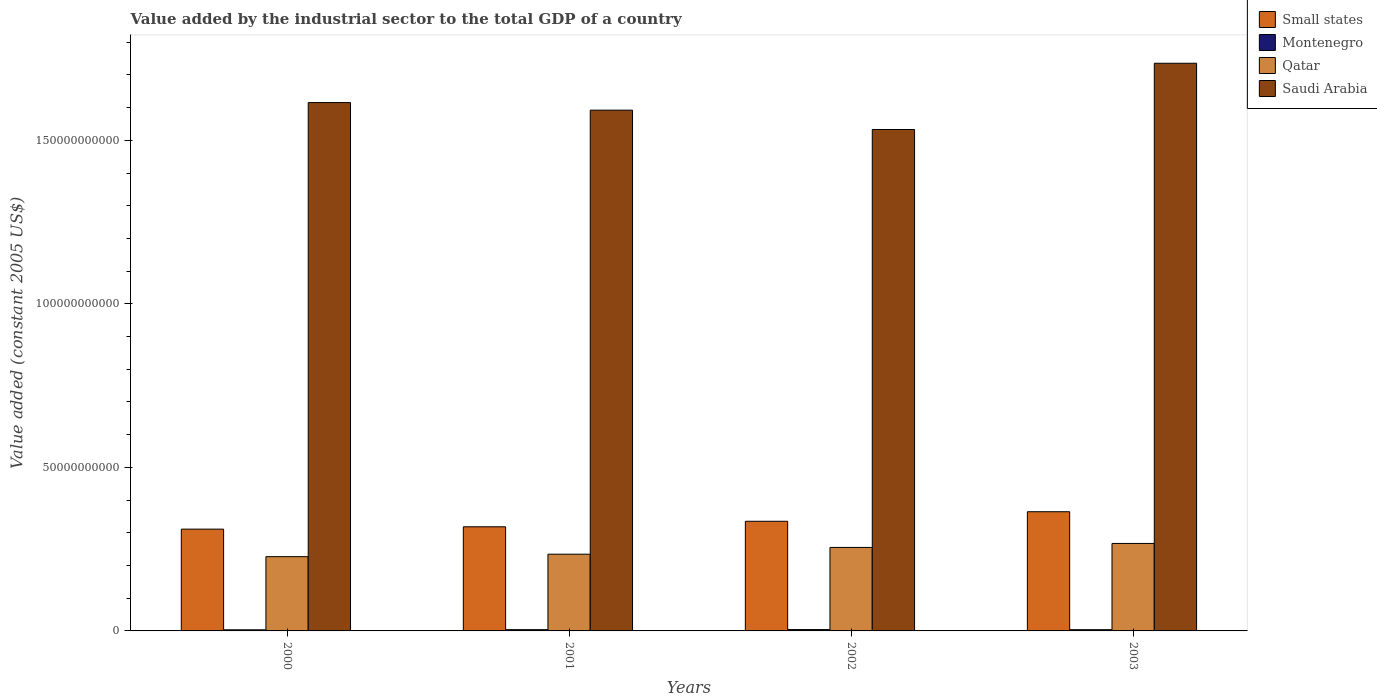How many different coloured bars are there?
Provide a succinct answer. 4. Are the number of bars per tick equal to the number of legend labels?
Keep it short and to the point. Yes. Are the number of bars on each tick of the X-axis equal?
Ensure brevity in your answer.  Yes. In how many cases, is the number of bars for a given year not equal to the number of legend labels?
Your answer should be compact. 0. What is the value added by the industrial sector in Small states in 2001?
Provide a succinct answer. 3.18e+1. Across all years, what is the maximum value added by the industrial sector in Montenegro?
Your answer should be very brief. 4.10e+08. Across all years, what is the minimum value added by the industrial sector in Montenegro?
Your answer should be compact. 3.32e+08. In which year was the value added by the industrial sector in Qatar maximum?
Keep it short and to the point. 2003. In which year was the value added by the industrial sector in Qatar minimum?
Your response must be concise. 2000. What is the total value added by the industrial sector in Saudi Arabia in the graph?
Provide a short and direct response. 6.48e+11. What is the difference between the value added by the industrial sector in Qatar in 2001 and that in 2002?
Offer a terse response. -2.07e+09. What is the difference between the value added by the industrial sector in Small states in 2000 and the value added by the industrial sector in Saudi Arabia in 2001?
Provide a short and direct response. -1.28e+11. What is the average value added by the industrial sector in Small states per year?
Offer a terse response. 3.32e+1. In the year 2000, what is the difference between the value added by the industrial sector in Saudi Arabia and value added by the industrial sector in Small states?
Your answer should be compact. 1.30e+11. What is the ratio of the value added by the industrial sector in Saudi Arabia in 2000 to that in 2001?
Provide a succinct answer. 1.01. Is the difference between the value added by the industrial sector in Saudi Arabia in 2000 and 2001 greater than the difference between the value added by the industrial sector in Small states in 2000 and 2001?
Keep it short and to the point. Yes. What is the difference between the highest and the second highest value added by the industrial sector in Qatar?
Your response must be concise. 1.22e+09. What is the difference between the highest and the lowest value added by the industrial sector in Small states?
Provide a short and direct response. 5.32e+09. In how many years, is the value added by the industrial sector in Small states greater than the average value added by the industrial sector in Small states taken over all years?
Give a very brief answer. 2. Is it the case that in every year, the sum of the value added by the industrial sector in Saudi Arabia and value added by the industrial sector in Qatar is greater than the sum of value added by the industrial sector in Small states and value added by the industrial sector in Montenegro?
Your response must be concise. Yes. What does the 3rd bar from the left in 2000 represents?
Keep it short and to the point. Qatar. What does the 4th bar from the right in 2003 represents?
Offer a very short reply. Small states. Is it the case that in every year, the sum of the value added by the industrial sector in Qatar and value added by the industrial sector in Small states is greater than the value added by the industrial sector in Saudi Arabia?
Provide a succinct answer. No. Are all the bars in the graph horizontal?
Provide a succinct answer. No. How many years are there in the graph?
Your response must be concise. 4. What is the difference between two consecutive major ticks on the Y-axis?
Keep it short and to the point. 5.00e+1. Are the values on the major ticks of Y-axis written in scientific E-notation?
Provide a succinct answer. No. Does the graph contain any zero values?
Your response must be concise. No. Does the graph contain grids?
Provide a short and direct response. No. How many legend labels are there?
Provide a succinct answer. 4. How are the legend labels stacked?
Provide a succinct answer. Vertical. What is the title of the graph?
Your response must be concise. Value added by the industrial sector to the total GDP of a country. Does "Tonga" appear as one of the legend labels in the graph?
Provide a short and direct response. No. What is the label or title of the Y-axis?
Make the answer very short. Value added (constant 2005 US$). What is the Value added (constant 2005 US$) in Small states in 2000?
Keep it short and to the point. 3.11e+1. What is the Value added (constant 2005 US$) in Montenegro in 2000?
Offer a terse response. 3.32e+08. What is the Value added (constant 2005 US$) of Qatar in 2000?
Give a very brief answer. 2.27e+1. What is the Value added (constant 2005 US$) in Saudi Arabia in 2000?
Provide a short and direct response. 1.62e+11. What is the Value added (constant 2005 US$) in Small states in 2001?
Your response must be concise. 3.18e+1. What is the Value added (constant 2005 US$) in Montenegro in 2001?
Offer a terse response. 3.83e+08. What is the Value added (constant 2005 US$) in Qatar in 2001?
Provide a short and direct response. 2.35e+1. What is the Value added (constant 2005 US$) in Saudi Arabia in 2001?
Ensure brevity in your answer.  1.59e+11. What is the Value added (constant 2005 US$) in Small states in 2002?
Offer a terse response. 3.35e+1. What is the Value added (constant 2005 US$) of Montenegro in 2002?
Keep it short and to the point. 4.10e+08. What is the Value added (constant 2005 US$) in Qatar in 2002?
Provide a short and direct response. 2.55e+1. What is the Value added (constant 2005 US$) in Saudi Arabia in 2002?
Provide a succinct answer. 1.53e+11. What is the Value added (constant 2005 US$) in Small states in 2003?
Offer a very short reply. 3.64e+1. What is the Value added (constant 2005 US$) of Montenegro in 2003?
Keep it short and to the point. 3.77e+08. What is the Value added (constant 2005 US$) in Qatar in 2003?
Your answer should be very brief. 2.67e+1. What is the Value added (constant 2005 US$) in Saudi Arabia in 2003?
Provide a short and direct response. 1.74e+11. Across all years, what is the maximum Value added (constant 2005 US$) in Small states?
Make the answer very short. 3.64e+1. Across all years, what is the maximum Value added (constant 2005 US$) of Montenegro?
Your answer should be compact. 4.10e+08. Across all years, what is the maximum Value added (constant 2005 US$) of Qatar?
Provide a succinct answer. 2.67e+1. Across all years, what is the maximum Value added (constant 2005 US$) in Saudi Arabia?
Provide a short and direct response. 1.74e+11. Across all years, what is the minimum Value added (constant 2005 US$) of Small states?
Your response must be concise. 3.11e+1. Across all years, what is the minimum Value added (constant 2005 US$) in Montenegro?
Offer a very short reply. 3.32e+08. Across all years, what is the minimum Value added (constant 2005 US$) in Qatar?
Make the answer very short. 2.27e+1. Across all years, what is the minimum Value added (constant 2005 US$) in Saudi Arabia?
Offer a terse response. 1.53e+11. What is the total Value added (constant 2005 US$) of Small states in the graph?
Offer a terse response. 1.33e+11. What is the total Value added (constant 2005 US$) of Montenegro in the graph?
Ensure brevity in your answer.  1.50e+09. What is the total Value added (constant 2005 US$) in Qatar in the graph?
Offer a very short reply. 9.84e+1. What is the total Value added (constant 2005 US$) of Saudi Arabia in the graph?
Offer a very short reply. 6.48e+11. What is the difference between the Value added (constant 2005 US$) in Small states in 2000 and that in 2001?
Keep it short and to the point. -7.15e+08. What is the difference between the Value added (constant 2005 US$) in Montenegro in 2000 and that in 2001?
Provide a short and direct response. -5.11e+07. What is the difference between the Value added (constant 2005 US$) in Qatar in 2000 and that in 2001?
Make the answer very short. -7.55e+08. What is the difference between the Value added (constant 2005 US$) in Saudi Arabia in 2000 and that in 2001?
Your answer should be compact. 2.31e+09. What is the difference between the Value added (constant 2005 US$) in Small states in 2000 and that in 2002?
Your response must be concise. -2.40e+09. What is the difference between the Value added (constant 2005 US$) of Montenegro in 2000 and that in 2002?
Ensure brevity in your answer.  -7.79e+07. What is the difference between the Value added (constant 2005 US$) of Qatar in 2000 and that in 2002?
Keep it short and to the point. -2.82e+09. What is the difference between the Value added (constant 2005 US$) of Saudi Arabia in 2000 and that in 2002?
Keep it short and to the point. 8.23e+09. What is the difference between the Value added (constant 2005 US$) of Small states in 2000 and that in 2003?
Keep it short and to the point. -5.32e+09. What is the difference between the Value added (constant 2005 US$) in Montenegro in 2000 and that in 2003?
Your answer should be very brief. -4.47e+07. What is the difference between the Value added (constant 2005 US$) of Qatar in 2000 and that in 2003?
Offer a terse response. -4.04e+09. What is the difference between the Value added (constant 2005 US$) in Saudi Arabia in 2000 and that in 2003?
Provide a succinct answer. -1.20e+1. What is the difference between the Value added (constant 2005 US$) of Small states in 2001 and that in 2002?
Offer a very short reply. -1.69e+09. What is the difference between the Value added (constant 2005 US$) of Montenegro in 2001 and that in 2002?
Offer a very short reply. -2.69e+07. What is the difference between the Value added (constant 2005 US$) of Qatar in 2001 and that in 2002?
Give a very brief answer. -2.07e+09. What is the difference between the Value added (constant 2005 US$) of Saudi Arabia in 2001 and that in 2002?
Provide a short and direct response. 5.92e+09. What is the difference between the Value added (constant 2005 US$) in Small states in 2001 and that in 2003?
Ensure brevity in your answer.  -4.60e+09. What is the difference between the Value added (constant 2005 US$) of Montenegro in 2001 and that in 2003?
Your answer should be very brief. 6.39e+06. What is the difference between the Value added (constant 2005 US$) in Qatar in 2001 and that in 2003?
Your answer should be compact. -3.29e+09. What is the difference between the Value added (constant 2005 US$) of Saudi Arabia in 2001 and that in 2003?
Ensure brevity in your answer.  -1.43e+1. What is the difference between the Value added (constant 2005 US$) in Small states in 2002 and that in 2003?
Offer a terse response. -2.92e+09. What is the difference between the Value added (constant 2005 US$) of Montenegro in 2002 and that in 2003?
Offer a terse response. 3.33e+07. What is the difference between the Value added (constant 2005 US$) of Qatar in 2002 and that in 2003?
Your response must be concise. -1.22e+09. What is the difference between the Value added (constant 2005 US$) of Saudi Arabia in 2002 and that in 2003?
Offer a terse response. -2.03e+1. What is the difference between the Value added (constant 2005 US$) of Small states in 2000 and the Value added (constant 2005 US$) of Montenegro in 2001?
Ensure brevity in your answer.  3.07e+1. What is the difference between the Value added (constant 2005 US$) of Small states in 2000 and the Value added (constant 2005 US$) of Qatar in 2001?
Offer a very short reply. 7.66e+09. What is the difference between the Value added (constant 2005 US$) of Small states in 2000 and the Value added (constant 2005 US$) of Saudi Arabia in 2001?
Offer a terse response. -1.28e+11. What is the difference between the Value added (constant 2005 US$) of Montenegro in 2000 and the Value added (constant 2005 US$) of Qatar in 2001?
Keep it short and to the point. -2.31e+1. What is the difference between the Value added (constant 2005 US$) in Montenegro in 2000 and the Value added (constant 2005 US$) in Saudi Arabia in 2001?
Offer a terse response. -1.59e+11. What is the difference between the Value added (constant 2005 US$) in Qatar in 2000 and the Value added (constant 2005 US$) in Saudi Arabia in 2001?
Your answer should be very brief. -1.37e+11. What is the difference between the Value added (constant 2005 US$) of Small states in 2000 and the Value added (constant 2005 US$) of Montenegro in 2002?
Provide a succinct answer. 3.07e+1. What is the difference between the Value added (constant 2005 US$) of Small states in 2000 and the Value added (constant 2005 US$) of Qatar in 2002?
Offer a terse response. 5.60e+09. What is the difference between the Value added (constant 2005 US$) of Small states in 2000 and the Value added (constant 2005 US$) of Saudi Arabia in 2002?
Keep it short and to the point. -1.22e+11. What is the difference between the Value added (constant 2005 US$) in Montenegro in 2000 and the Value added (constant 2005 US$) in Qatar in 2002?
Ensure brevity in your answer.  -2.52e+1. What is the difference between the Value added (constant 2005 US$) in Montenegro in 2000 and the Value added (constant 2005 US$) in Saudi Arabia in 2002?
Make the answer very short. -1.53e+11. What is the difference between the Value added (constant 2005 US$) of Qatar in 2000 and the Value added (constant 2005 US$) of Saudi Arabia in 2002?
Offer a terse response. -1.31e+11. What is the difference between the Value added (constant 2005 US$) in Small states in 2000 and the Value added (constant 2005 US$) in Montenegro in 2003?
Your response must be concise. 3.07e+1. What is the difference between the Value added (constant 2005 US$) of Small states in 2000 and the Value added (constant 2005 US$) of Qatar in 2003?
Make the answer very short. 4.38e+09. What is the difference between the Value added (constant 2005 US$) of Small states in 2000 and the Value added (constant 2005 US$) of Saudi Arabia in 2003?
Make the answer very short. -1.42e+11. What is the difference between the Value added (constant 2005 US$) in Montenegro in 2000 and the Value added (constant 2005 US$) in Qatar in 2003?
Keep it short and to the point. -2.64e+1. What is the difference between the Value added (constant 2005 US$) in Montenegro in 2000 and the Value added (constant 2005 US$) in Saudi Arabia in 2003?
Your answer should be very brief. -1.73e+11. What is the difference between the Value added (constant 2005 US$) of Qatar in 2000 and the Value added (constant 2005 US$) of Saudi Arabia in 2003?
Offer a very short reply. -1.51e+11. What is the difference between the Value added (constant 2005 US$) of Small states in 2001 and the Value added (constant 2005 US$) of Montenegro in 2002?
Ensure brevity in your answer.  3.14e+1. What is the difference between the Value added (constant 2005 US$) in Small states in 2001 and the Value added (constant 2005 US$) in Qatar in 2002?
Your response must be concise. 6.31e+09. What is the difference between the Value added (constant 2005 US$) of Small states in 2001 and the Value added (constant 2005 US$) of Saudi Arabia in 2002?
Your answer should be very brief. -1.21e+11. What is the difference between the Value added (constant 2005 US$) of Montenegro in 2001 and the Value added (constant 2005 US$) of Qatar in 2002?
Give a very brief answer. -2.51e+1. What is the difference between the Value added (constant 2005 US$) in Montenegro in 2001 and the Value added (constant 2005 US$) in Saudi Arabia in 2002?
Provide a short and direct response. -1.53e+11. What is the difference between the Value added (constant 2005 US$) in Qatar in 2001 and the Value added (constant 2005 US$) in Saudi Arabia in 2002?
Your answer should be very brief. -1.30e+11. What is the difference between the Value added (constant 2005 US$) in Small states in 2001 and the Value added (constant 2005 US$) in Montenegro in 2003?
Your response must be concise. 3.15e+1. What is the difference between the Value added (constant 2005 US$) in Small states in 2001 and the Value added (constant 2005 US$) in Qatar in 2003?
Ensure brevity in your answer.  5.09e+09. What is the difference between the Value added (constant 2005 US$) of Small states in 2001 and the Value added (constant 2005 US$) of Saudi Arabia in 2003?
Ensure brevity in your answer.  -1.42e+11. What is the difference between the Value added (constant 2005 US$) in Montenegro in 2001 and the Value added (constant 2005 US$) in Qatar in 2003?
Provide a succinct answer. -2.64e+1. What is the difference between the Value added (constant 2005 US$) of Montenegro in 2001 and the Value added (constant 2005 US$) of Saudi Arabia in 2003?
Keep it short and to the point. -1.73e+11. What is the difference between the Value added (constant 2005 US$) in Qatar in 2001 and the Value added (constant 2005 US$) in Saudi Arabia in 2003?
Provide a short and direct response. -1.50e+11. What is the difference between the Value added (constant 2005 US$) in Small states in 2002 and the Value added (constant 2005 US$) in Montenegro in 2003?
Make the answer very short. 3.31e+1. What is the difference between the Value added (constant 2005 US$) of Small states in 2002 and the Value added (constant 2005 US$) of Qatar in 2003?
Offer a very short reply. 6.78e+09. What is the difference between the Value added (constant 2005 US$) in Small states in 2002 and the Value added (constant 2005 US$) in Saudi Arabia in 2003?
Ensure brevity in your answer.  -1.40e+11. What is the difference between the Value added (constant 2005 US$) of Montenegro in 2002 and the Value added (constant 2005 US$) of Qatar in 2003?
Your answer should be compact. -2.63e+1. What is the difference between the Value added (constant 2005 US$) of Montenegro in 2002 and the Value added (constant 2005 US$) of Saudi Arabia in 2003?
Give a very brief answer. -1.73e+11. What is the difference between the Value added (constant 2005 US$) of Qatar in 2002 and the Value added (constant 2005 US$) of Saudi Arabia in 2003?
Keep it short and to the point. -1.48e+11. What is the average Value added (constant 2005 US$) of Small states per year?
Ensure brevity in your answer.  3.32e+1. What is the average Value added (constant 2005 US$) in Montenegro per year?
Your answer should be very brief. 3.76e+08. What is the average Value added (constant 2005 US$) of Qatar per year?
Give a very brief answer. 2.46e+1. What is the average Value added (constant 2005 US$) of Saudi Arabia per year?
Make the answer very short. 1.62e+11. In the year 2000, what is the difference between the Value added (constant 2005 US$) in Small states and Value added (constant 2005 US$) in Montenegro?
Ensure brevity in your answer.  3.08e+1. In the year 2000, what is the difference between the Value added (constant 2005 US$) of Small states and Value added (constant 2005 US$) of Qatar?
Offer a very short reply. 8.42e+09. In the year 2000, what is the difference between the Value added (constant 2005 US$) in Small states and Value added (constant 2005 US$) in Saudi Arabia?
Offer a very short reply. -1.30e+11. In the year 2000, what is the difference between the Value added (constant 2005 US$) of Montenegro and Value added (constant 2005 US$) of Qatar?
Provide a short and direct response. -2.24e+1. In the year 2000, what is the difference between the Value added (constant 2005 US$) in Montenegro and Value added (constant 2005 US$) in Saudi Arabia?
Ensure brevity in your answer.  -1.61e+11. In the year 2000, what is the difference between the Value added (constant 2005 US$) of Qatar and Value added (constant 2005 US$) of Saudi Arabia?
Keep it short and to the point. -1.39e+11. In the year 2001, what is the difference between the Value added (constant 2005 US$) of Small states and Value added (constant 2005 US$) of Montenegro?
Your answer should be compact. 3.15e+1. In the year 2001, what is the difference between the Value added (constant 2005 US$) in Small states and Value added (constant 2005 US$) in Qatar?
Keep it short and to the point. 8.38e+09. In the year 2001, what is the difference between the Value added (constant 2005 US$) in Small states and Value added (constant 2005 US$) in Saudi Arabia?
Offer a terse response. -1.27e+11. In the year 2001, what is the difference between the Value added (constant 2005 US$) of Montenegro and Value added (constant 2005 US$) of Qatar?
Give a very brief answer. -2.31e+1. In the year 2001, what is the difference between the Value added (constant 2005 US$) of Montenegro and Value added (constant 2005 US$) of Saudi Arabia?
Offer a terse response. -1.59e+11. In the year 2001, what is the difference between the Value added (constant 2005 US$) of Qatar and Value added (constant 2005 US$) of Saudi Arabia?
Make the answer very short. -1.36e+11. In the year 2002, what is the difference between the Value added (constant 2005 US$) of Small states and Value added (constant 2005 US$) of Montenegro?
Give a very brief answer. 3.31e+1. In the year 2002, what is the difference between the Value added (constant 2005 US$) in Small states and Value added (constant 2005 US$) in Qatar?
Offer a very short reply. 8.00e+09. In the year 2002, what is the difference between the Value added (constant 2005 US$) in Small states and Value added (constant 2005 US$) in Saudi Arabia?
Offer a terse response. -1.20e+11. In the year 2002, what is the difference between the Value added (constant 2005 US$) of Montenegro and Value added (constant 2005 US$) of Qatar?
Ensure brevity in your answer.  -2.51e+1. In the year 2002, what is the difference between the Value added (constant 2005 US$) in Montenegro and Value added (constant 2005 US$) in Saudi Arabia?
Make the answer very short. -1.53e+11. In the year 2002, what is the difference between the Value added (constant 2005 US$) of Qatar and Value added (constant 2005 US$) of Saudi Arabia?
Keep it short and to the point. -1.28e+11. In the year 2003, what is the difference between the Value added (constant 2005 US$) of Small states and Value added (constant 2005 US$) of Montenegro?
Make the answer very short. 3.61e+1. In the year 2003, what is the difference between the Value added (constant 2005 US$) in Small states and Value added (constant 2005 US$) in Qatar?
Ensure brevity in your answer.  9.70e+09. In the year 2003, what is the difference between the Value added (constant 2005 US$) of Small states and Value added (constant 2005 US$) of Saudi Arabia?
Offer a very short reply. -1.37e+11. In the year 2003, what is the difference between the Value added (constant 2005 US$) of Montenegro and Value added (constant 2005 US$) of Qatar?
Keep it short and to the point. -2.64e+1. In the year 2003, what is the difference between the Value added (constant 2005 US$) of Montenegro and Value added (constant 2005 US$) of Saudi Arabia?
Keep it short and to the point. -1.73e+11. In the year 2003, what is the difference between the Value added (constant 2005 US$) of Qatar and Value added (constant 2005 US$) of Saudi Arabia?
Offer a terse response. -1.47e+11. What is the ratio of the Value added (constant 2005 US$) of Small states in 2000 to that in 2001?
Offer a very short reply. 0.98. What is the ratio of the Value added (constant 2005 US$) in Montenegro in 2000 to that in 2001?
Make the answer very short. 0.87. What is the ratio of the Value added (constant 2005 US$) in Qatar in 2000 to that in 2001?
Your answer should be compact. 0.97. What is the ratio of the Value added (constant 2005 US$) of Saudi Arabia in 2000 to that in 2001?
Ensure brevity in your answer.  1.01. What is the ratio of the Value added (constant 2005 US$) of Small states in 2000 to that in 2002?
Ensure brevity in your answer.  0.93. What is the ratio of the Value added (constant 2005 US$) of Montenegro in 2000 to that in 2002?
Make the answer very short. 0.81. What is the ratio of the Value added (constant 2005 US$) in Qatar in 2000 to that in 2002?
Keep it short and to the point. 0.89. What is the ratio of the Value added (constant 2005 US$) in Saudi Arabia in 2000 to that in 2002?
Provide a short and direct response. 1.05. What is the ratio of the Value added (constant 2005 US$) in Small states in 2000 to that in 2003?
Provide a short and direct response. 0.85. What is the ratio of the Value added (constant 2005 US$) in Montenegro in 2000 to that in 2003?
Offer a very short reply. 0.88. What is the ratio of the Value added (constant 2005 US$) in Qatar in 2000 to that in 2003?
Provide a succinct answer. 0.85. What is the ratio of the Value added (constant 2005 US$) of Saudi Arabia in 2000 to that in 2003?
Keep it short and to the point. 0.93. What is the ratio of the Value added (constant 2005 US$) in Small states in 2001 to that in 2002?
Offer a very short reply. 0.95. What is the ratio of the Value added (constant 2005 US$) in Montenegro in 2001 to that in 2002?
Your answer should be compact. 0.93. What is the ratio of the Value added (constant 2005 US$) of Qatar in 2001 to that in 2002?
Give a very brief answer. 0.92. What is the ratio of the Value added (constant 2005 US$) of Saudi Arabia in 2001 to that in 2002?
Keep it short and to the point. 1.04. What is the ratio of the Value added (constant 2005 US$) of Small states in 2001 to that in 2003?
Give a very brief answer. 0.87. What is the ratio of the Value added (constant 2005 US$) of Montenegro in 2001 to that in 2003?
Offer a terse response. 1.02. What is the ratio of the Value added (constant 2005 US$) of Qatar in 2001 to that in 2003?
Your answer should be compact. 0.88. What is the ratio of the Value added (constant 2005 US$) of Saudi Arabia in 2001 to that in 2003?
Offer a terse response. 0.92. What is the ratio of the Value added (constant 2005 US$) of Small states in 2002 to that in 2003?
Make the answer very short. 0.92. What is the ratio of the Value added (constant 2005 US$) in Montenegro in 2002 to that in 2003?
Ensure brevity in your answer.  1.09. What is the ratio of the Value added (constant 2005 US$) in Qatar in 2002 to that in 2003?
Offer a terse response. 0.95. What is the ratio of the Value added (constant 2005 US$) of Saudi Arabia in 2002 to that in 2003?
Offer a very short reply. 0.88. What is the difference between the highest and the second highest Value added (constant 2005 US$) in Small states?
Offer a very short reply. 2.92e+09. What is the difference between the highest and the second highest Value added (constant 2005 US$) of Montenegro?
Your answer should be compact. 2.69e+07. What is the difference between the highest and the second highest Value added (constant 2005 US$) in Qatar?
Ensure brevity in your answer.  1.22e+09. What is the difference between the highest and the second highest Value added (constant 2005 US$) in Saudi Arabia?
Provide a succinct answer. 1.20e+1. What is the difference between the highest and the lowest Value added (constant 2005 US$) in Small states?
Keep it short and to the point. 5.32e+09. What is the difference between the highest and the lowest Value added (constant 2005 US$) in Montenegro?
Provide a short and direct response. 7.79e+07. What is the difference between the highest and the lowest Value added (constant 2005 US$) in Qatar?
Your answer should be very brief. 4.04e+09. What is the difference between the highest and the lowest Value added (constant 2005 US$) in Saudi Arabia?
Your answer should be compact. 2.03e+1. 